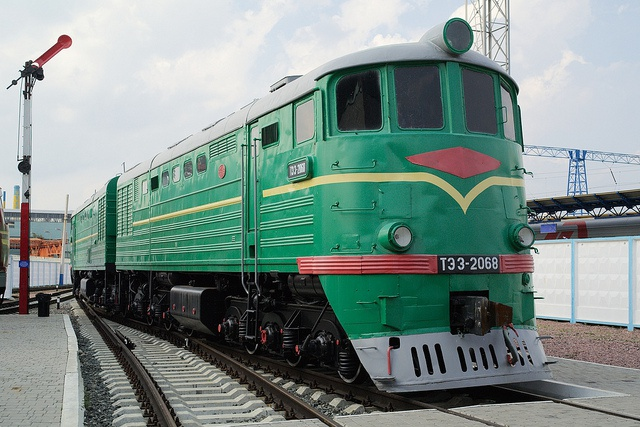Describe the objects in this image and their specific colors. I can see a train in lightgray, black, teal, and darkgray tones in this image. 